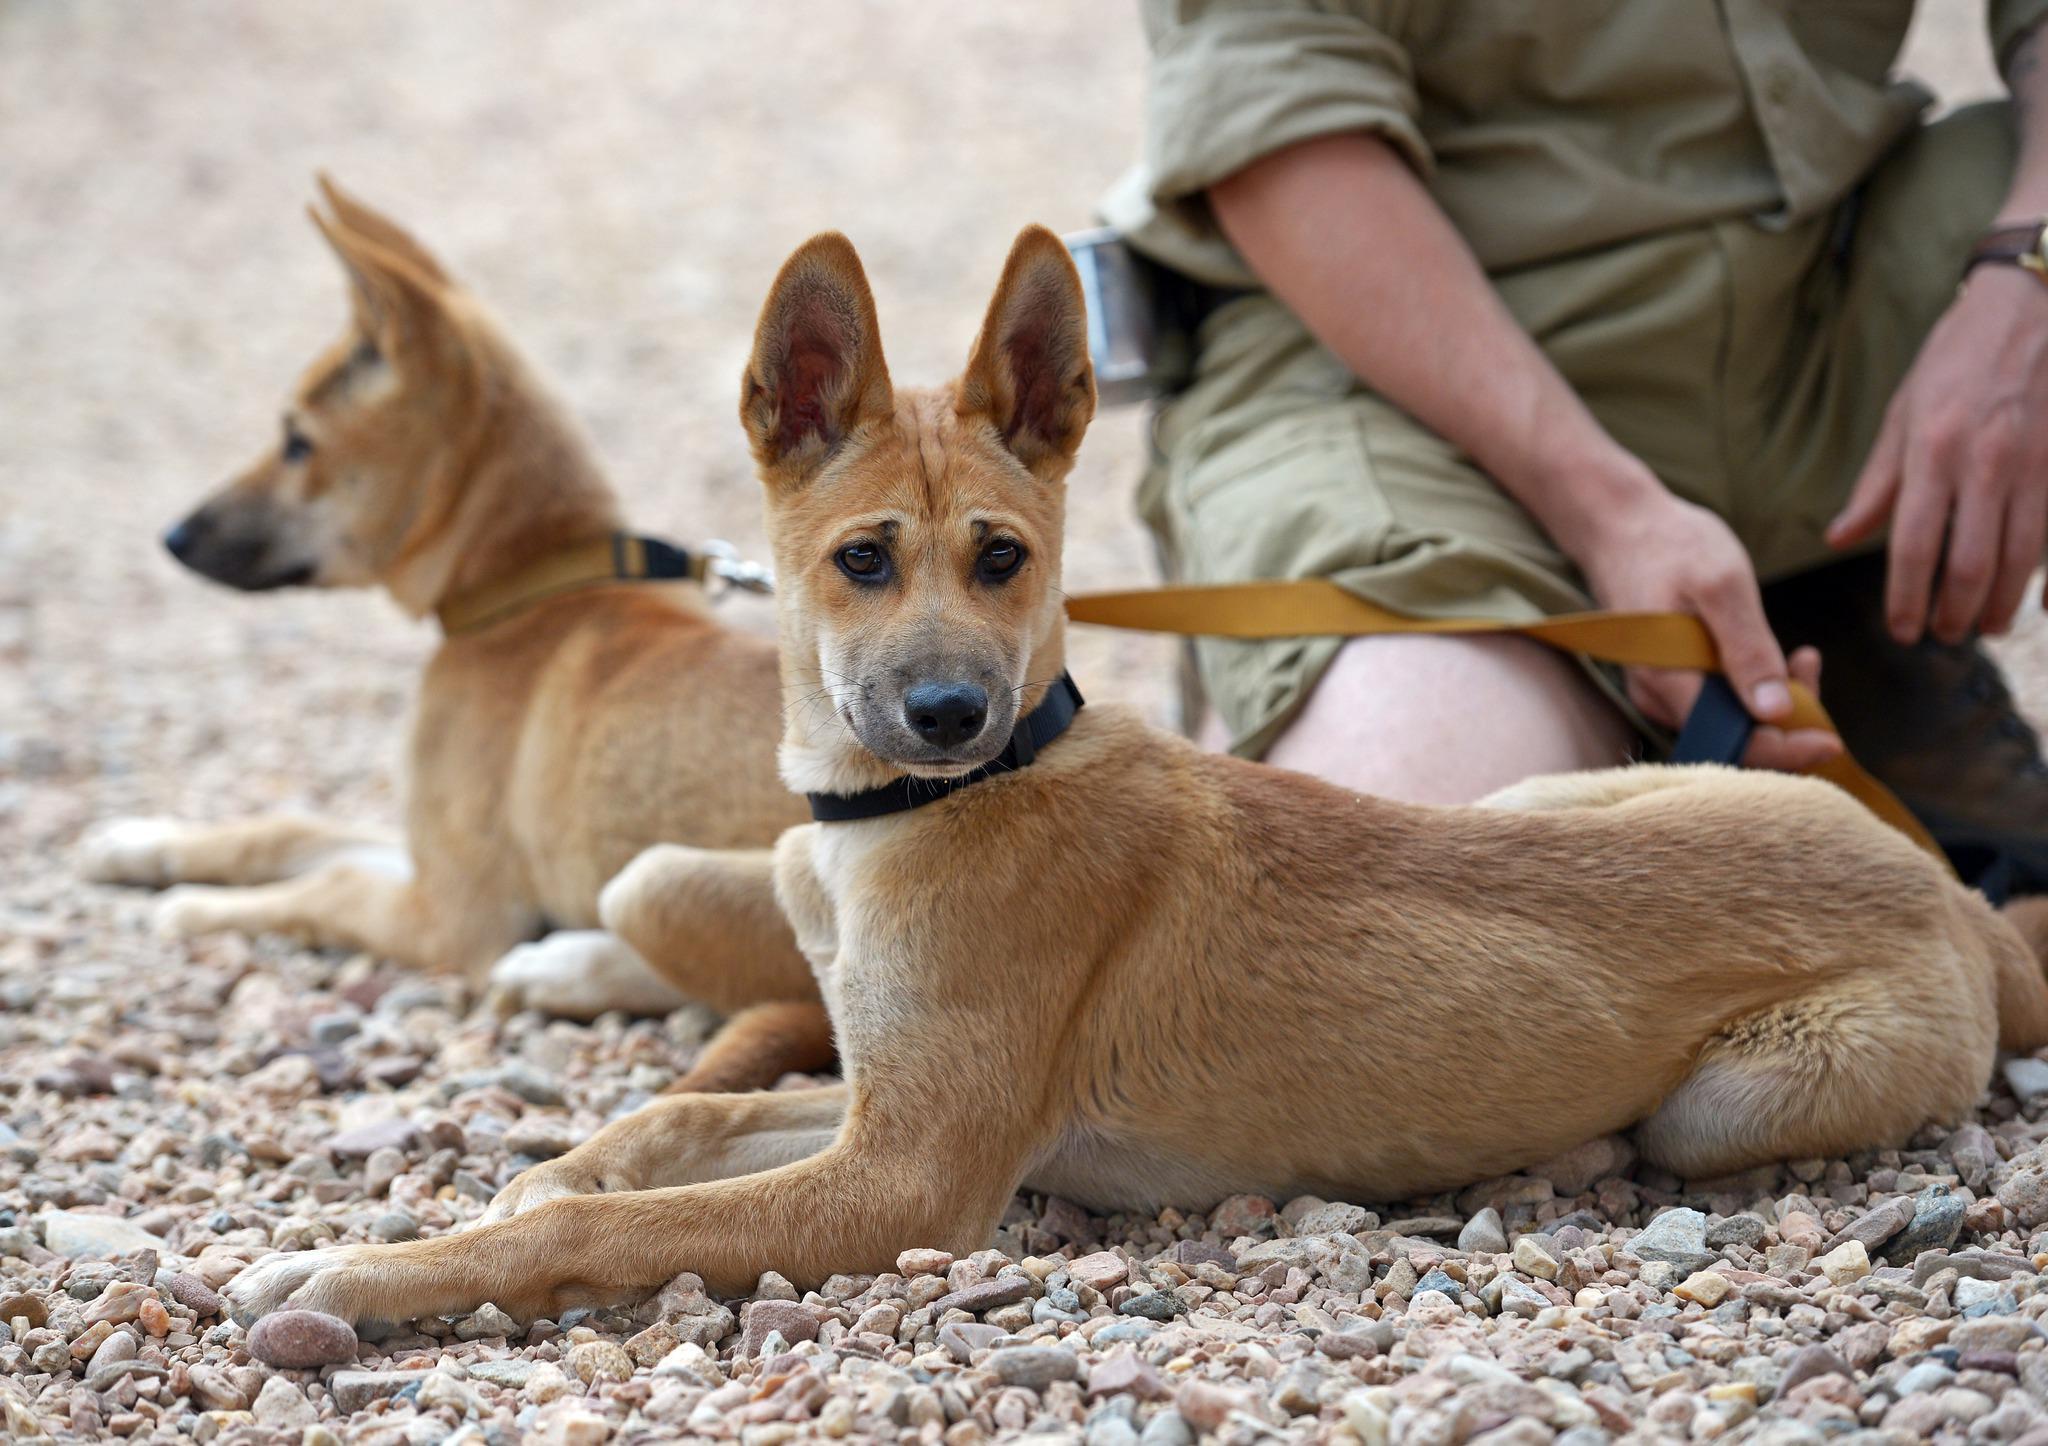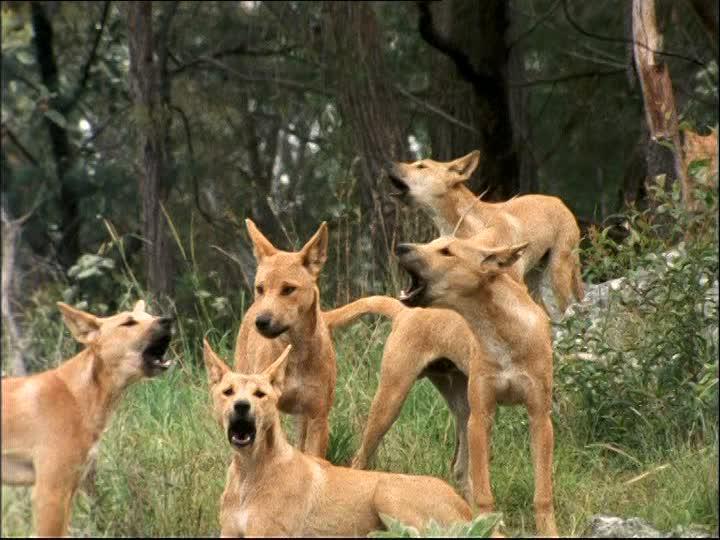The first image is the image on the left, the second image is the image on the right. Evaluate the accuracy of this statement regarding the images: "There are two dogs total on both images.". Is it true? Answer yes or no. No. 